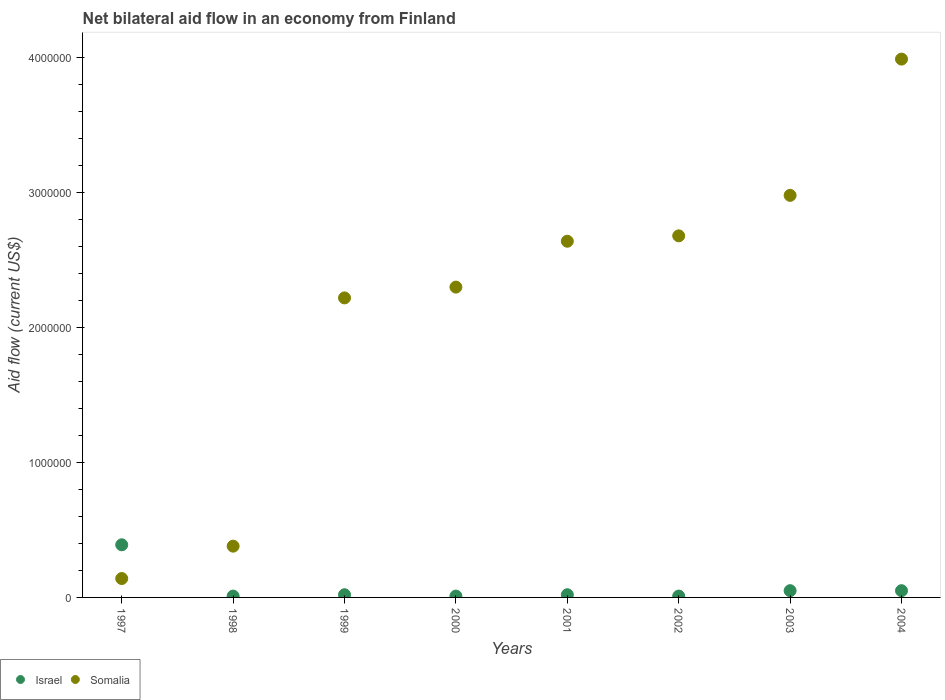Is the number of dotlines equal to the number of legend labels?
Ensure brevity in your answer.  Yes. What is the net bilateral aid flow in Somalia in 2004?
Make the answer very short. 3.99e+06. In which year was the net bilateral aid flow in Israel maximum?
Your answer should be very brief. 1997. In which year was the net bilateral aid flow in Israel minimum?
Provide a short and direct response. 1998. What is the total net bilateral aid flow in Israel in the graph?
Provide a succinct answer. 5.60e+05. What is the average net bilateral aid flow in Somalia per year?
Your response must be concise. 2.17e+06. In the year 1999, what is the difference between the net bilateral aid flow in Somalia and net bilateral aid flow in Israel?
Make the answer very short. 2.20e+06. In how many years, is the net bilateral aid flow in Israel greater than 400000 US$?
Give a very brief answer. 0. What is the ratio of the net bilateral aid flow in Somalia in 2001 to that in 2003?
Give a very brief answer. 0.89. Is the net bilateral aid flow in Somalia in 2000 less than that in 2004?
Give a very brief answer. Yes. What is the difference between the highest and the second highest net bilateral aid flow in Somalia?
Make the answer very short. 1.01e+06. In how many years, is the net bilateral aid flow in Somalia greater than the average net bilateral aid flow in Somalia taken over all years?
Keep it short and to the point. 6. Does the net bilateral aid flow in Somalia monotonically increase over the years?
Ensure brevity in your answer.  Yes. Is the net bilateral aid flow in Somalia strictly greater than the net bilateral aid flow in Israel over the years?
Your answer should be very brief. No. Is the net bilateral aid flow in Somalia strictly less than the net bilateral aid flow in Israel over the years?
Make the answer very short. No. How many dotlines are there?
Make the answer very short. 2. What is the difference between two consecutive major ticks on the Y-axis?
Keep it short and to the point. 1.00e+06. Where does the legend appear in the graph?
Offer a very short reply. Bottom left. How are the legend labels stacked?
Provide a short and direct response. Horizontal. What is the title of the graph?
Offer a terse response. Net bilateral aid flow in an economy from Finland. What is the label or title of the Y-axis?
Make the answer very short. Aid flow (current US$). What is the Aid flow (current US$) in Somalia in 1997?
Give a very brief answer. 1.40e+05. What is the Aid flow (current US$) in Israel in 1998?
Provide a succinct answer. 10000. What is the Aid flow (current US$) in Somalia in 1998?
Your answer should be compact. 3.80e+05. What is the Aid flow (current US$) in Somalia in 1999?
Your answer should be compact. 2.22e+06. What is the Aid flow (current US$) of Israel in 2000?
Give a very brief answer. 10000. What is the Aid flow (current US$) of Somalia in 2000?
Make the answer very short. 2.30e+06. What is the Aid flow (current US$) in Somalia in 2001?
Give a very brief answer. 2.64e+06. What is the Aid flow (current US$) in Israel in 2002?
Provide a succinct answer. 10000. What is the Aid flow (current US$) in Somalia in 2002?
Give a very brief answer. 2.68e+06. What is the Aid flow (current US$) of Somalia in 2003?
Ensure brevity in your answer.  2.98e+06. What is the Aid flow (current US$) in Israel in 2004?
Your response must be concise. 5.00e+04. What is the Aid flow (current US$) in Somalia in 2004?
Offer a very short reply. 3.99e+06. Across all years, what is the maximum Aid flow (current US$) of Somalia?
Offer a terse response. 3.99e+06. Across all years, what is the minimum Aid flow (current US$) of Somalia?
Ensure brevity in your answer.  1.40e+05. What is the total Aid flow (current US$) in Israel in the graph?
Your answer should be very brief. 5.60e+05. What is the total Aid flow (current US$) of Somalia in the graph?
Provide a short and direct response. 1.73e+07. What is the difference between the Aid flow (current US$) in Somalia in 1997 and that in 1999?
Your answer should be compact. -2.08e+06. What is the difference between the Aid flow (current US$) in Israel in 1997 and that in 2000?
Make the answer very short. 3.80e+05. What is the difference between the Aid flow (current US$) in Somalia in 1997 and that in 2000?
Provide a succinct answer. -2.16e+06. What is the difference between the Aid flow (current US$) of Somalia in 1997 and that in 2001?
Your answer should be very brief. -2.50e+06. What is the difference between the Aid flow (current US$) of Somalia in 1997 and that in 2002?
Keep it short and to the point. -2.54e+06. What is the difference between the Aid flow (current US$) in Israel in 1997 and that in 2003?
Provide a short and direct response. 3.40e+05. What is the difference between the Aid flow (current US$) of Somalia in 1997 and that in 2003?
Your answer should be very brief. -2.84e+06. What is the difference between the Aid flow (current US$) in Somalia in 1997 and that in 2004?
Ensure brevity in your answer.  -3.85e+06. What is the difference between the Aid flow (current US$) of Israel in 1998 and that in 1999?
Keep it short and to the point. -10000. What is the difference between the Aid flow (current US$) in Somalia in 1998 and that in 1999?
Provide a short and direct response. -1.84e+06. What is the difference between the Aid flow (current US$) of Somalia in 1998 and that in 2000?
Your answer should be compact. -1.92e+06. What is the difference between the Aid flow (current US$) in Israel in 1998 and that in 2001?
Your answer should be compact. -10000. What is the difference between the Aid flow (current US$) of Somalia in 1998 and that in 2001?
Provide a succinct answer. -2.26e+06. What is the difference between the Aid flow (current US$) in Somalia in 1998 and that in 2002?
Ensure brevity in your answer.  -2.30e+06. What is the difference between the Aid flow (current US$) of Somalia in 1998 and that in 2003?
Provide a succinct answer. -2.60e+06. What is the difference between the Aid flow (current US$) of Somalia in 1998 and that in 2004?
Make the answer very short. -3.61e+06. What is the difference between the Aid flow (current US$) in Israel in 1999 and that in 2001?
Provide a succinct answer. 0. What is the difference between the Aid flow (current US$) in Somalia in 1999 and that in 2001?
Provide a succinct answer. -4.20e+05. What is the difference between the Aid flow (current US$) in Somalia in 1999 and that in 2002?
Offer a very short reply. -4.60e+05. What is the difference between the Aid flow (current US$) of Somalia in 1999 and that in 2003?
Your response must be concise. -7.60e+05. What is the difference between the Aid flow (current US$) of Israel in 1999 and that in 2004?
Your answer should be very brief. -3.00e+04. What is the difference between the Aid flow (current US$) in Somalia in 1999 and that in 2004?
Provide a short and direct response. -1.77e+06. What is the difference between the Aid flow (current US$) in Somalia in 2000 and that in 2002?
Keep it short and to the point. -3.80e+05. What is the difference between the Aid flow (current US$) in Israel in 2000 and that in 2003?
Provide a short and direct response. -4.00e+04. What is the difference between the Aid flow (current US$) of Somalia in 2000 and that in 2003?
Provide a short and direct response. -6.80e+05. What is the difference between the Aid flow (current US$) in Somalia in 2000 and that in 2004?
Offer a very short reply. -1.69e+06. What is the difference between the Aid flow (current US$) in Somalia in 2001 and that in 2002?
Make the answer very short. -4.00e+04. What is the difference between the Aid flow (current US$) of Somalia in 2001 and that in 2003?
Provide a succinct answer. -3.40e+05. What is the difference between the Aid flow (current US$) of Somalia in 2001 and that in 2004?
Offer a very short reply. -1.35e+06. What is the difference between the Aid flow (current US$) of Israel in 2002 and that in 2003?
Provide a succinct answer. -4.00e+04. What is the difference between the Aid flow (current US$) of Somalia in 2002 and that in 2003?
Your response must be concise. -3.00e+05. What is the difference between the Aid flow (current US$) of Israel in 2002 and that in 2004?
Make the answer very short. -4.00e+04. What is the difference between the Aid flow (current US$) of Somalia in 2002 and that in 2004?
Provide a succinct answer. -1.31e+06. What is the difference between the Aid flow (current US$) of Israel in 2003 and that in 2004?
Provide a short and direct response. 0. What is the difference between the Aid flow (current US$) of Somalia in 2003 and that in 2004?
Make the answer very short. -1.01e+06. What is the difference between the Aid flow (current US$) of Israel in 1997 and the Aid flow (current US$) of Somalia in 1999?
Provide a succinct answer. -1.83e+06. What is the difference between the Aid flow (current US$) of Israel in 1997 and the Aid flow (current US$) of Somalia in 2000?
Your response must be concise. -1.91e+06. What is the difference between the Aid flow (current US$) of Israel in 1997 and the Aid flow (current US$) of Somalia in 2001?
Provide a succinct answer. -2.25e+06. What is the difference between the Aid flow (current US$) of Israel in 1997 and the Aid flow (current US$) of Somalia in 2002?
Offer a very short reply. -2.29e+06. What is the difference between the Aid flow (current US$) of Israel in 1997 and the Aid flow (current US$) of Somalia in 2003?
Give a very brief answer. -2.59e+06. What is the difference between the Aid flow (current US$) in Israel in 1997 and the Aid flow (current US$) in Somalia in 2004?
Your answer should be very brief. -3.60e+06. What is the difference between the Aid flow (current US$) in Israel in 1998 and the Aid flow (current US$) in Somalia in 1999?
Keep it short and to the point. -2.21e+06. What is the difference between the Aid flow (current US$) in Israel in 1998 and the Aid flow (current US$) in Somalia in 2000?
Your answer should be compact. -2.29e+06. What is the difference between the Aid flow (current US$) of Israel in 1998 and the Aid flow (current US$) of Somalia in 2001?
Keep it short and to the point. -2.63e+06. What is the difference between the Aid flow (current US$) in Israel in 1998 and the Aid flow (current US$) in Somalia in 2002?
Provide a succinct answer. -2.67e+06. What is the difference between the Aid flow (current US$) in Israel in 1998 and the Aid flow (current US$) in Somalia in 2003?
Provide a short and direct response. -2.97e+06. What is the difference between the Aid flow (current US$) in Israel in 1998 and the Aid flow (current US$) in Somalia in 2004?
Offer a terse response. -3.98e+06. What is the difference between the Aid flow (current US$) of Israel in 1999 and the Aid flow (current US$) of Somalia in 2000?
Your response must be concise. -2.28e+06. What is the difference between the Aid flow (current US$) of Israel in 1999 and the Aid flow (current US$) of Somalia in 2001?
Ensure brevity in your answer.  -2.62e+06. What is the difference between the Aid flow (current US$) of Israel in 1999 and the Aid flow (current US$) of Somalia in 2002?
Provide a succinct answer. -2.66e+06. What is the difference between the Aid flow (current US$) in Israel in 1999 and the Aid flow (current US$) in Somalia in 2003?
Ensure brevity in your answer.  -2.96e+06. What is the difference between the Aid flow (current US$) of Israel in 1999 and the Aid flow (current US$) of Somalia in 2004?
Make the answer very short. -3.97e+06. What is the difference between the Aid flow (current US$) in Israel in 2000 and the Aid flow (current US$) in Somalia in 2001?
Keep it short and to the point. -2.63e+06. What is the difference between the Aid flow (current US$) in Israel in 2000 and the Aid flow (current US$) in Somalia in 2002?
Your answer should be very brief. -2.67e+06. What is the difference between the Aid flow (current US$) in Israel in 2000 and the Aid flow (current US$) in Somalia in 2003?
Ensure brevity in your answer.  -2.97e+06. What is the difference between the Aid flow (current US$) in Israel in 2000 and the Aid flow (current US$) in Somalia in 2004?
Provide a succinct answer. -3.98e+06. What is the difference between the Aid flow (current US$) in Israel in 2001 and the Aid flow (current US$) in Somalia in 2002?
Provide a short and direct response. -2.66e+06. What is the difference between the Aid flow (current US$) in Israel in 2001 and the Aid flow (current US$) in Somalia in 2003?
Keep it short and to the point. -2.96e+06. What is the difference between the Aid flow (current US$) of Israel in 2001 and the Aid flow (current US$) of Somalia in 2004?
Offer a very short reply. -3.97e+06. What is the difference between the Aid flow (current US$) in Israel in 2002 and the Aid flow (current US$) in Somalia in 2003?
Your answer should be very brief. -2.97e+06. What is the difference between the Aid flow (current US$) in Israel in 2002 and the Aid flow (current US$) in Somalia in 2004?
Provide a succinct answer. -3.98e+06. What is the difference between the Aid flow (current US$) of Israel in 2003 and the Aid flow (current US$) of Somalia in 2004?
Give a very brief answer. -3.94e+06. What is the average Aid flow (current US$) of Israel per year?
Ensure brevity in your answer.  7.00e+04. What is the average Aid flow (current US$) of Somalia per year?
Your response must be concise. 2.17e+06. In the year 1997, what is the difference between the Aid flow (current US$) of Israel and Aid flow (current US$) of Somalia?
Make the answer very short. 2.50e+05. In the year 1998, what is the difference between the Aid flow (current US$) of Israel and Aid flow (current US$) of Somalia?
Provide a short and direct response. -3.70e+05. In the year 1999, what is the difference between the Aid flow (current US$) in Israel and Aid flow (current US$) in Somalia?
Offer a very short reply. -2.20e+06. In the year 2000, what is the difference between the Aid flow (current US$) of Israel and Aid flow (current US$) of Somalia?
Provide a short and direct response. -2.29e+06. In the year 2001, what is the difference between the Aid flow (current US$) in Israel and Aid flow (current US$) in Somalia?
Make the answer very short. -2.62e+06. In the year 2002, what is the difference between the Aid flow (current US$) in Israel and Aid flow (current US$) in Somalia?
Give a very brief answer. -2.67e+06. In the year 2003, what is the difference between the Aid flow (current US$) of Israel and Aid flow (current US$) of Somalia?
Offer a very short reply. -2.93e+06. In the year 2004, what is the difference between the Aid flow (current US$) in Israel and Aid flow (current US$) in Somalia?
Provide a succinct answer. -3.94e+06. What is the ratio of the Aid flow (current US$) of Somalia in 1997 to that in 1998?
Your answer should be very brief. 0.37. What is the ratio of the Aid flow (current US$) in Somalia in 1997 to that in 1999?
Give a very brief answer. 0.06. What is the ratio of the Aid flow (current US$) of Somalia in 1997 to that in 2000?
Your answer should be very brief. 0.06. What is the ratio of the Aid flow (current US$) of Israel in 1997 to that in 2001?
Keep it short and to the point. 19.5. What is the ratio of the Aid flow (current US$) in Somalia in 1997 to that in 2001?
Ensure brevity in your answer.  0.05. What is the ratio of the Aid flow (current US$) of Somalia in 1997 to that in 2002?
Offer a very short reply. 0.05. What is the ratio of the Aid flow (current US$) of Somalia in 1997 to that in 2003?
Your answer should be compact. 0.05. What is the ratio of the Aid flow (current US$) in Somalia in 1997 to that in 2004?
Provide a short and direct response. 0.04. What is the ratio of the Aid flow (current US$) of Somalia in 1998 to that in 1999?
Keep it short and to the point. 0.17. What is the ratio of the Aid flow (current US$) in Israel in 1998 to that in 2000?
Your answer should be compact. 1. What is the ratio of the Aid flow (current US$) of Somalia in 1998 to that in 2000?
Ensure brevity in your answer.  0.17. What is the ratio of the Aid flow (current US$) of Somalia in 1998 to that in 2001?
Keep it short and to the point. 0.14. What is the ratio of the Aid flow (current US$) of Somalia in 1998 to that in 2002?
Keep it short and to the point. 0.14. What is the ratio of the Aid flow (current US$) of Israel in 1998 to that in 2003?
Make the answer very short. 0.2. What is the ratio of the Aid flow (current US$) in Somalia in 1998 to that in 2003?
Provide a succinct answer. 0.13. What is the ratio of the Aid flow (current US$) of Israel in 1998 to that in 2004?
Offer a terse response. 0.2. What is the ratio of the Aid flow (current US$) in Somalia in 1998 to that in 2004?
Offer a terse response. 0.1. What is the ratio of the Aid flow (current US$) of Somalia in 1999 to that in 2000?
Your response must be concise. 0.97. What is the ratio of the Aid flow (current US$) in Somalia in 1999 to that in 2001?
Ensure brevity in your answer.  0.84. What is the ratio of the Aid flow (current US$) of Israel in 1999 to that in 2002?
Provide a short and direct response. 2. What is the ratio of the Aid flow (current US$) in Somalia in 1999 to that in 2002?
Offer a very short reply. 0.83. What is the ratio of the Aid flow (current US$) in Somalia in 1999 to that in 2003?
Make the answer very short. 0.74. What is the ratio of the Aid flow (current US$) in Israel in 1999 to that in 2004?
Your response must be concise. 0.4. What is the ratio of the Aid flow (current US$) of Somalia in 1999 to that in 2004?
Make the answer very short. 0.56. What is the ratio of the Aid flow (current US$) of Israel in 2000 to that in 2001?
Keep it short and to the point. 0.5. What is the ratio of the Aid flow (current US$) of Somalia in 2000 to that in 2001?
Ensure brevity in your answer.  0.87. What is the ratio of the Aid flow (current US$) of Israel in 2000 to that in 2002?
Provide a short and direct response. 1. What is the ratio of the Aid flow (current US$) of Somalia in 2000 to that in 2002?
Provide a succinct answer. 0.86. What is the ratio of the Aid flow (current US$) in Somalia in 2000 to that in 2003?
Give a very brief answer. 0.77. What is the ratio of the Aid flow (current US$) in Somalia in 2000 to that in 2004?
Give a very brief answer. 0.58. What is the ratio of the Aid flow (current US$) in Somalia in 2001 to that in 2002?
Your answer should be compact. 0.99. What is the ratio of the Aid flow (current US$) of Somalia in 2001 to that in 2003?
Provide a succinct answer. 0.89. What is the ratio of the Aid flow (current US$) of Somalia in 2001 to that in 2004?
Ensure brevity in your answer.  0.66. What is the ratio of the Aid flow (current US$) of Israel in 2002 to that in 2003?
Keep it short and to the point. 0.2. What is the ratio of the Aid flow (current US$) of Somalia in 2002 to that in 2003?
Give a very brief answer. 0.9. What is the ratio of the Aid flow (current US$) of Somalia in 2002 to that in 2004?
Your answer should be very brief. 0.67. What is the ratio of the Aid flow (current US$) in Israel in 2003 to that in 2004?
Provide a short and direct response. 1. What is the ratio of the Aid flow (current US$) of Somalia in 2003 to that in 2004?
Provide a short and direct response. 0.75. What is the difference between the highest and the second highest Aid flow (current US$) in Israel?
Provide a short and direct response. 3.40e+05. What is the difference between the highest and the second highest Aid flow (current US$) of Somalia?
Ensure brevity in your answer.  1.01e+06. What is the difference between the highest and the lowest Aid flow (current US$) of Somalia?
Offer a terse response. 3.85e+06. 